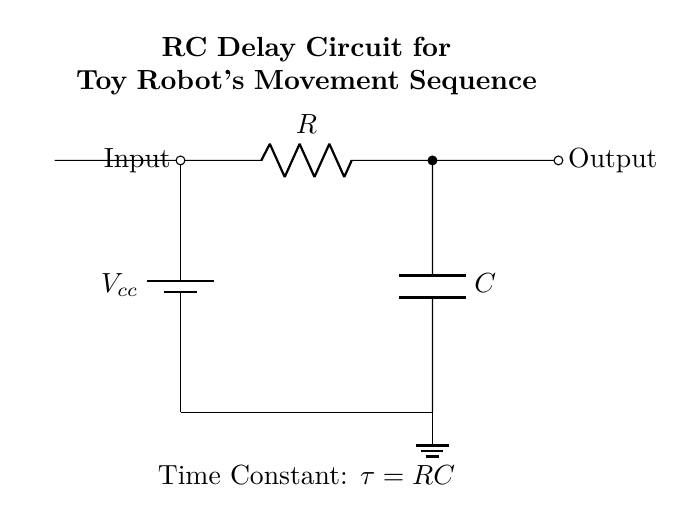What components are in this circuit? The circuit has a battery, resistor, and capacitor. These components can be identified as they are labeled in the diagram. The battery is the source, while the resistor and capacitor are connected in series.
Answer: battery, resistor, capacitor What is the purpose of the resistor in this circuit? The resistor limits the current that flows into the capacitor. This is crucial because it affects the charging time of the capacitor, which ultimately influences the delay in the toy robot's movement.
Answer: limit current What is the time constant of this circuit? The time constant is represented by the equation tau equals RC, where R is the resistance and C is the capacitance. This value determines how quickly the capacitor charges to approximately 63.2% of the supply voltage.
Answer: tau equals RC Where is the output taken in this circuit? The output is taken from the point after the capacitor, indicated by the output label to the right of the capacitor in the circuit diagram. This point provides the delayed signal for the robot's movement.
Answer: after the capacitor What happens to the output signal when the input is applied? When the input signal is applied, the capacitor begins to charge through the resistor. This charging process creates a delay in the output signal, due to the time constant which controls how quickly the capacitor charges.
Answer: creates a delay What does the icon of the robot represent in this circuit? The robot icon signifies the practical application of this RC delay circuit, indicating that this circuit is designed to control the timing of the toy robot’s movements.
Answer: toy robot's application What is shown by the ground symbol in the circuit? The ground symbol indicates the reference point in the circuit where the return path for current is established. It acts as a common return path and provides stability to the circuit.
Answer: reference point 